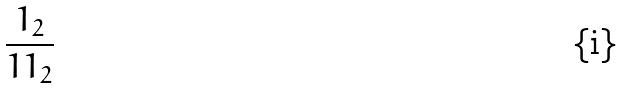Convert formula to latex. <formula><loc_0><loc_0><loc_500><loc_500>\frac { 1 _ { 2 } } { 1 1 _ { 2 } }</formula> 